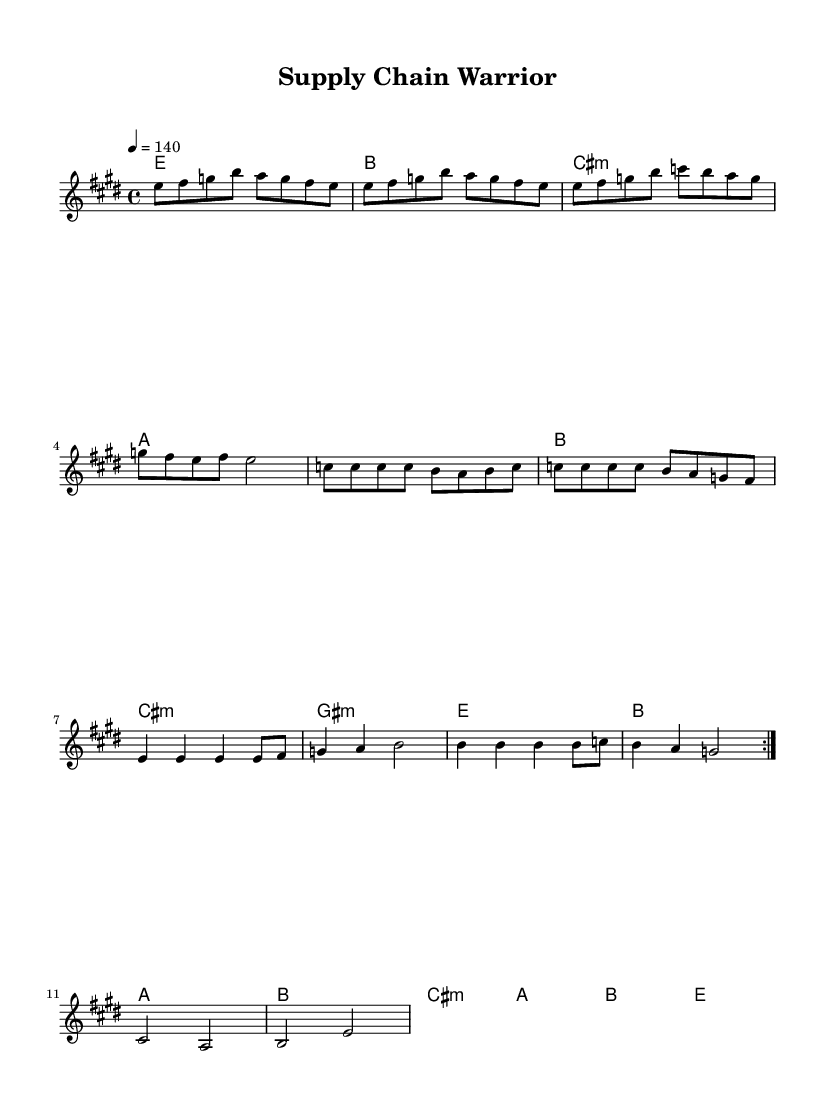What is the key signature of this music? The key signature is E major, indicated by the two sharps in the key signature at the beginning of the staff. The notes F# and C# are typically sharp in this key.
Answer: E major What is the time signature of this music? The time signature is 4/4, shown at the beginning of the staff as a fraction with four beats in a measure and a quarter note representing one beat.
Answer: 4/4 What is the tempo marking? The tempo marking is 140 BPM, indicated as "4 = 140" in the score, suggesting the quarter note gets one beat and the speed is set to 140 beats per minute.
Answer: 140 How many measures are in the verse before the pre-chorus? The verse consists of 8 measures, determined by counting the separate sections of music before the transition to the pre-chorus. There are two repeated sections of 4 measures each, totaling 8.
Answer: 8 What is the first chord of the chorus? The first chord of the chorus is E major, as indicated in the chord symbols written above the staff at the start of the chorus section.
Answer: E What is the relationship between the chorus and the pre-chorus chords? The choruses transition from E major to B major, while the pre-chorus progresses through A major, B major, and C# minor, indicating a strong movement from the pre-chorus to the more energetic chorus that resolves on E major. This showcases the buildup of energy and anticipation typical in rock anthems.
Answer: Strong What is the last note in the melody before the bridge? The last note in the melody before the bridge is E, marked as a half note, indicating the highest point of resolution before the contrasting section begins.
Answer: E 